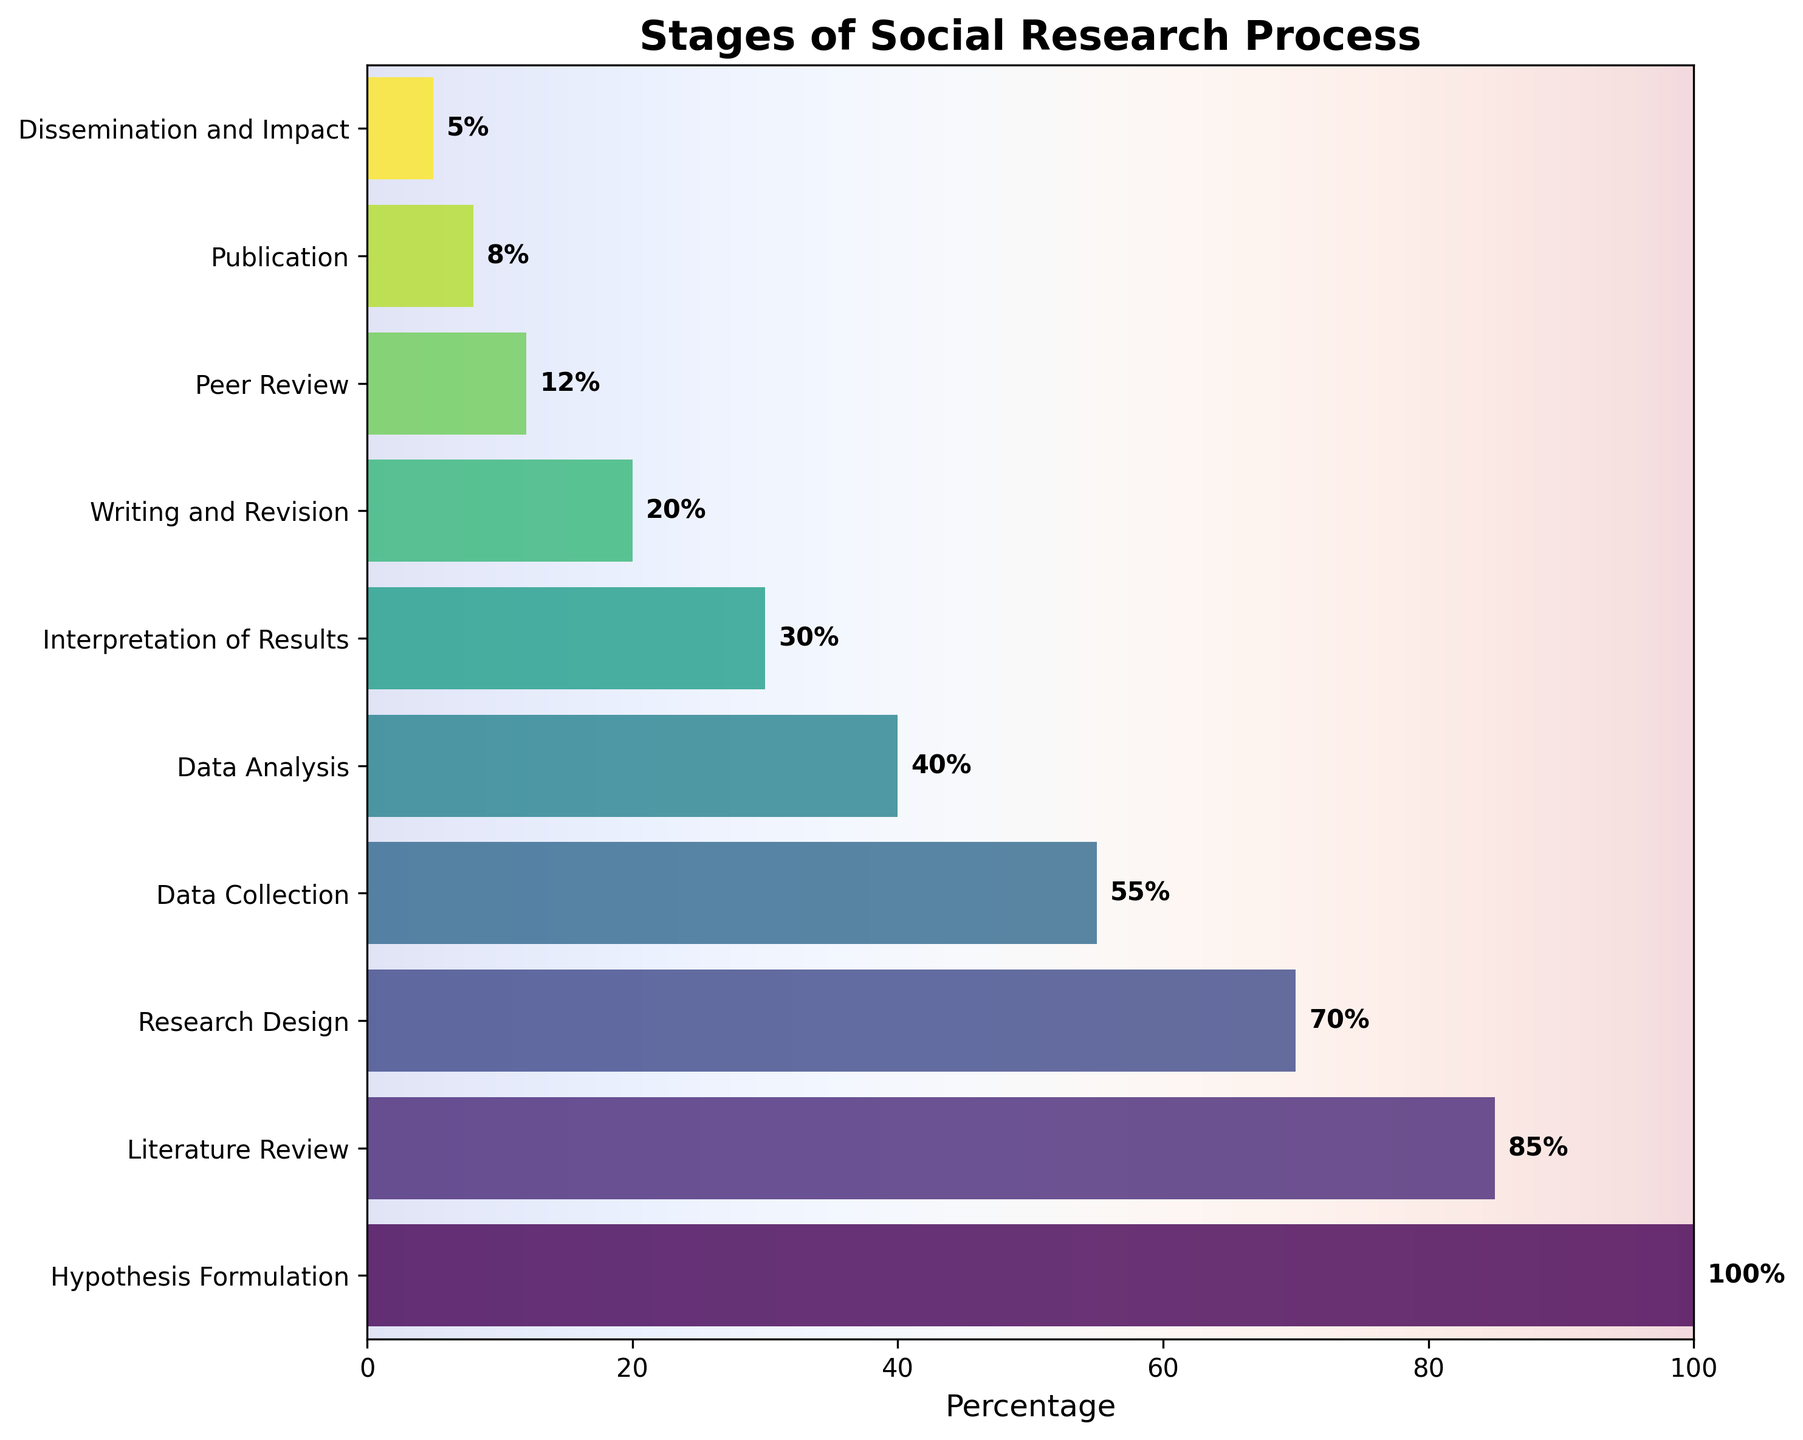What is the title of the figure? The title is found at the top of the chart and it summarizes the main topic of the figure.
Answer: Stages of Social Research Process What percentage of the research process is represented by Data Collection? Look at the bar labeled 'Data Collection' and read the percentage value associated with it.
Answer: 55% How many stages are listed in the research process? Count the number of horizontal bars or labels on the y-axis representing the different stages.
Answer: 10 Which stage shows a middle-point (approximately 50%) reduction from the initial Hypothesis Formulation stage? Identify the stage where the percentage is around 50% of the Hypothesis Formulation (100%).
Answer: Data Collection What is the difference in percentage between Writing and Revision and Peer Review? Find the values for both stages and subtract the percentage of Peer Review from Writing and Revision. 20% - 12%
Answer: 8% Compare the percentages of Publication and Dissemination and Impact, which one is higher? Look at the percentages associated with both stages and determine which one has a higher value.
Answer: Publication What is the average percentage of the final three stages? Calculate the average percentage of Peer Review, Publication, and Dissemination and Impact. (12+8+5)/3 = 8.33
Answer: 8.33% Is there a significant drop in percentage between any two consecutive stages? If so, which ones? Examine the differences between percentages of consecutive stages and identify the largest drop. E.g., between Research Design (70%) and Data Collection (55%), but essentially between Hypothesis Formulation and Literature Review there is a 15% drop.
Answer: Hypothesis Formulation to Literature Review At which stage is the process three-quarters completed? Find the stage that is closest to 25% as the stages reduce progressively.
Answer: Interpretation of Results 